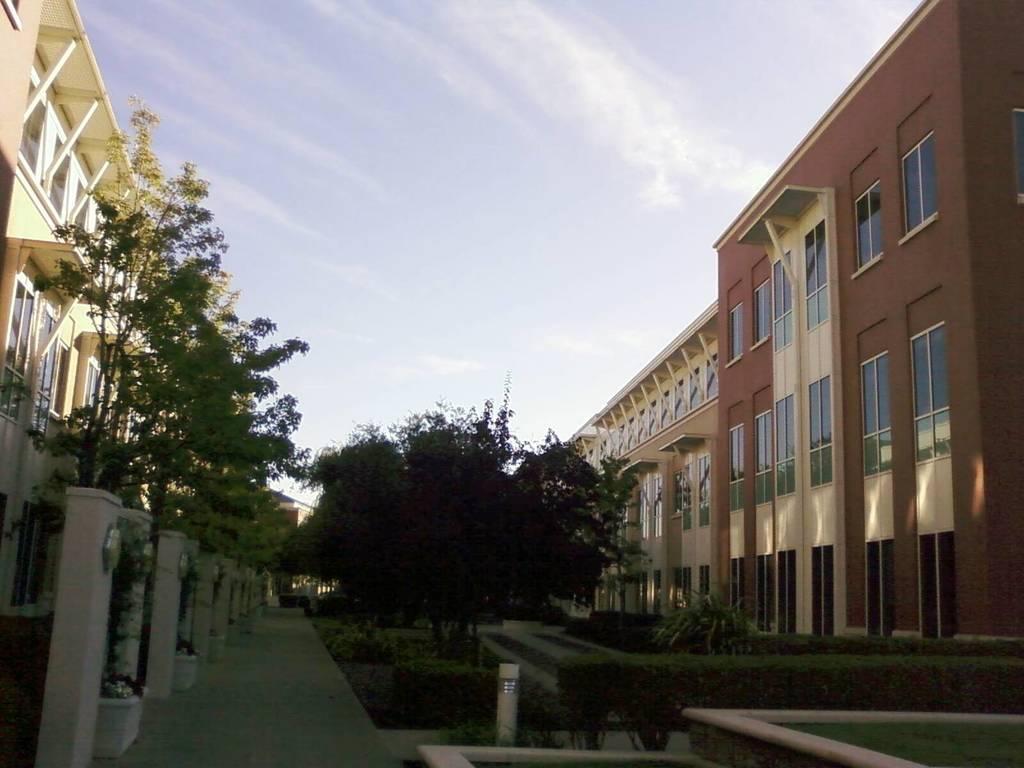Please provide a concise description of this image. In the middle of the image there are some trees and plants and buildings. At the top of the image there are some clouds and sky. 